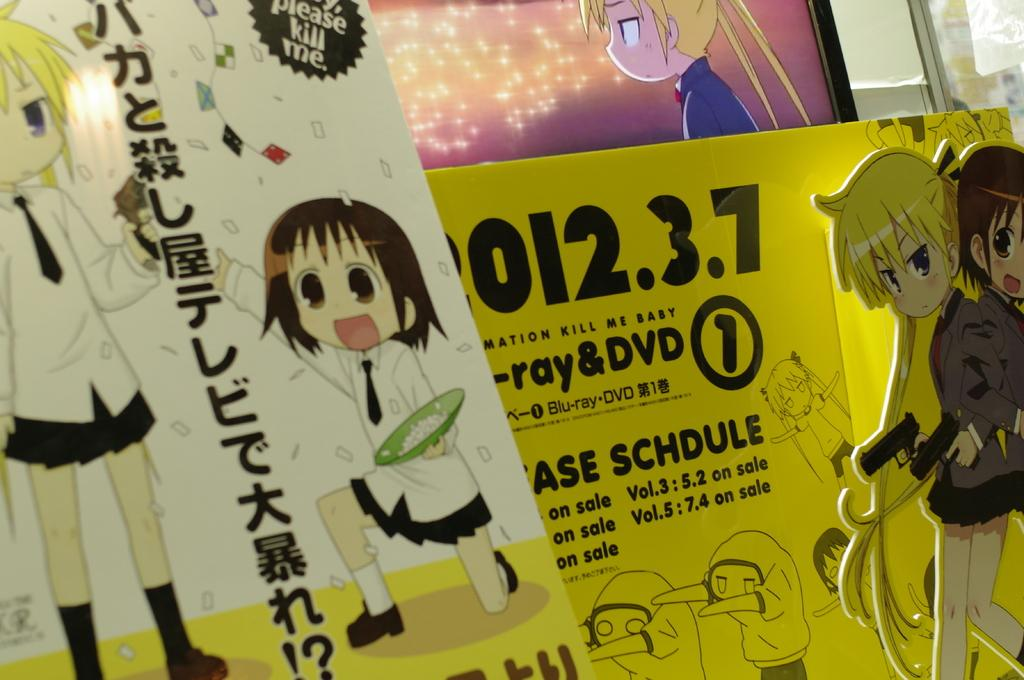What objects are in the foreground of the image? There are two boards in the foreground of the image. What is located at the top of the image? There is a screen on the top of the image. What type of cushion is placed on the sheet in the image? There is no cushion or sheet present in the image; only two boards and a screen are visible. 